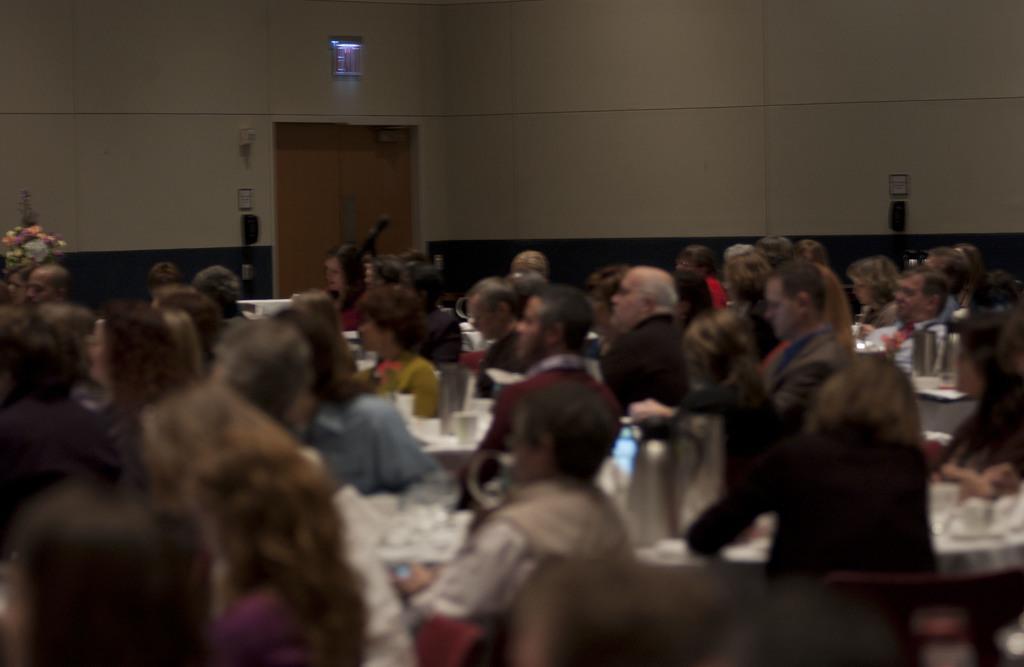Describe this image in one or two sentences. This picture shows few people seated on the chairs and we see tables and few classes on the table and a flower vase. 